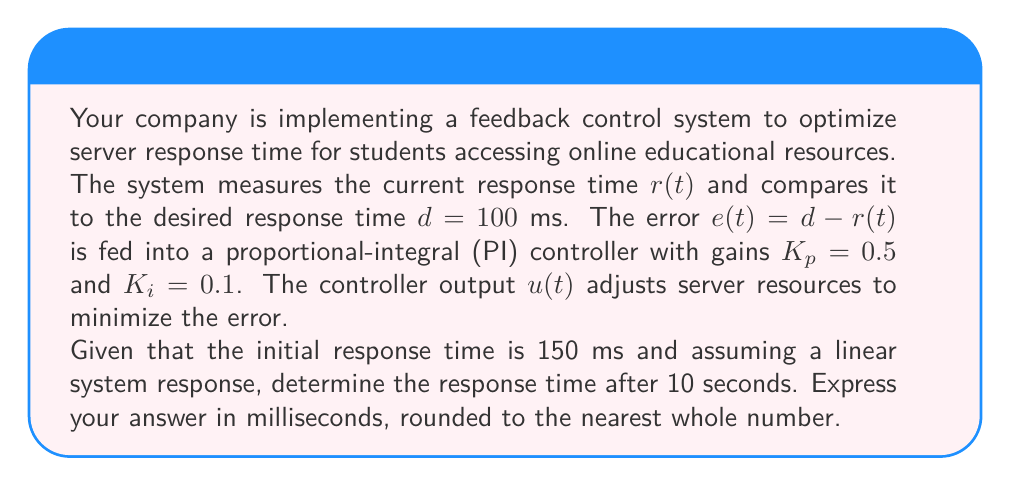Solve this math problem. To solve this problem, we'll use the principles of feedback control systems and the PI controller equation. Let's break it down step-by-step:

1) The PI controller equation is:

   $$u(t) = K_p e(t) + K_i \int_0^t e(\tau) d\tau$$

2) Initially, $e(0) = d - r(0) = 100 - 150 = -50$ ms

3) Assuming a linear system response, the error will decrease linearly over time. Let's represent the error as a function of time:

   $$e(t) = -50 + kt$$

   where $k$ is the rate of change of the error.

4) The integral term of the controller will be:

   $$\int_0^t e(\tau) d\tau = \int_0^t (-50 + k\tau) d\tau = -50t + \frac{1}{2}kt^2$$

5) Substituting into the PI controller equation:

   $$u(t) = K_p(-50 + kt) + K_i(-50t + \frac{1}{2}kt^2)$$

6) For the system to reach steady state at $t = 10$, we need $u(10) = 0$:

   $$0 = 0.5(-50 + 10k) + 0.1(-500 + 50k)$$

7) Solving for $k$:

   $$0 = -25 + 5k - 50 + 5k$$
   $$75 = 10k$$
   $$k = 7.5$$

8) Now we can find $e(10)$:

   $$e(10) = -50 + 7.5 * 10 = 25$$

9) Therefore, the final error is 25 ms, meaning the response time after 10 seconds is:

   $$r(10) = d - e(10) = 100 - 25 = 75$$ ms
Answer: 75 ms 